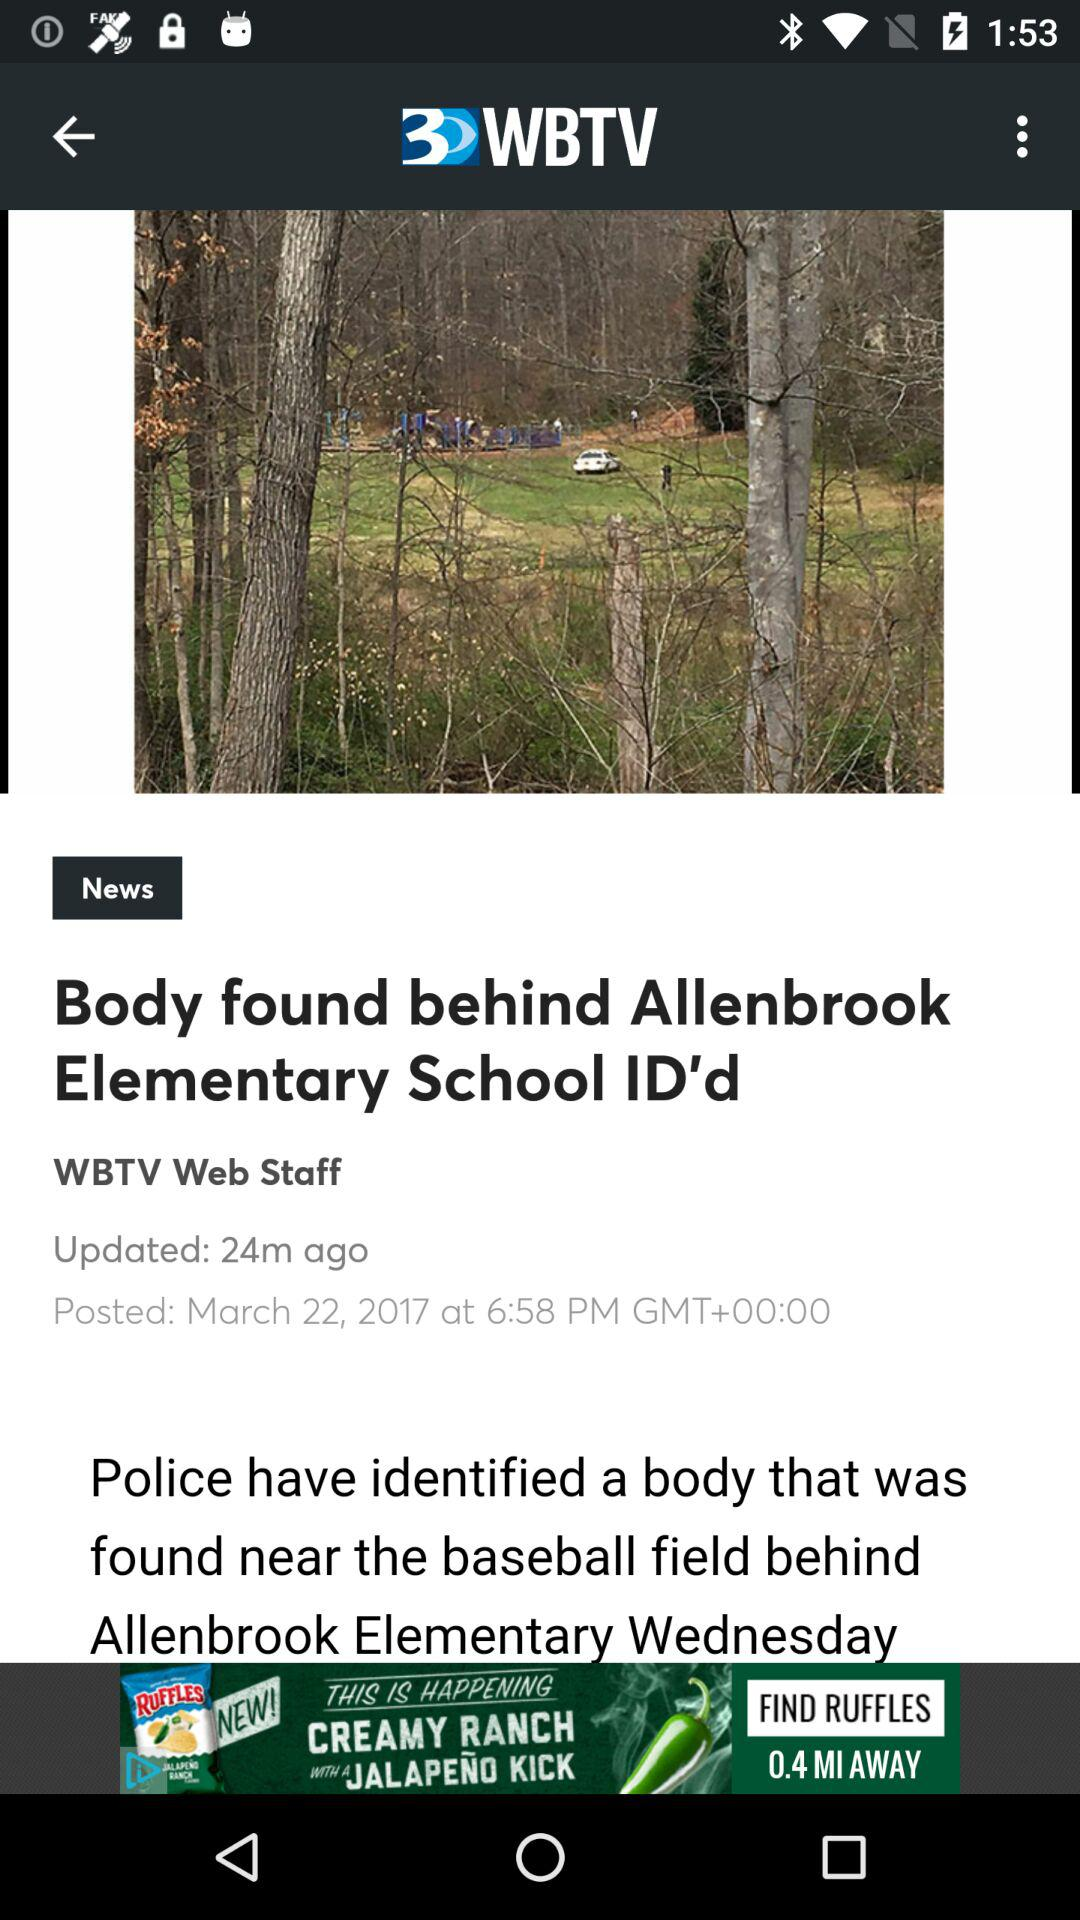When was the article updated? The article was updated 24 minutes ago. 